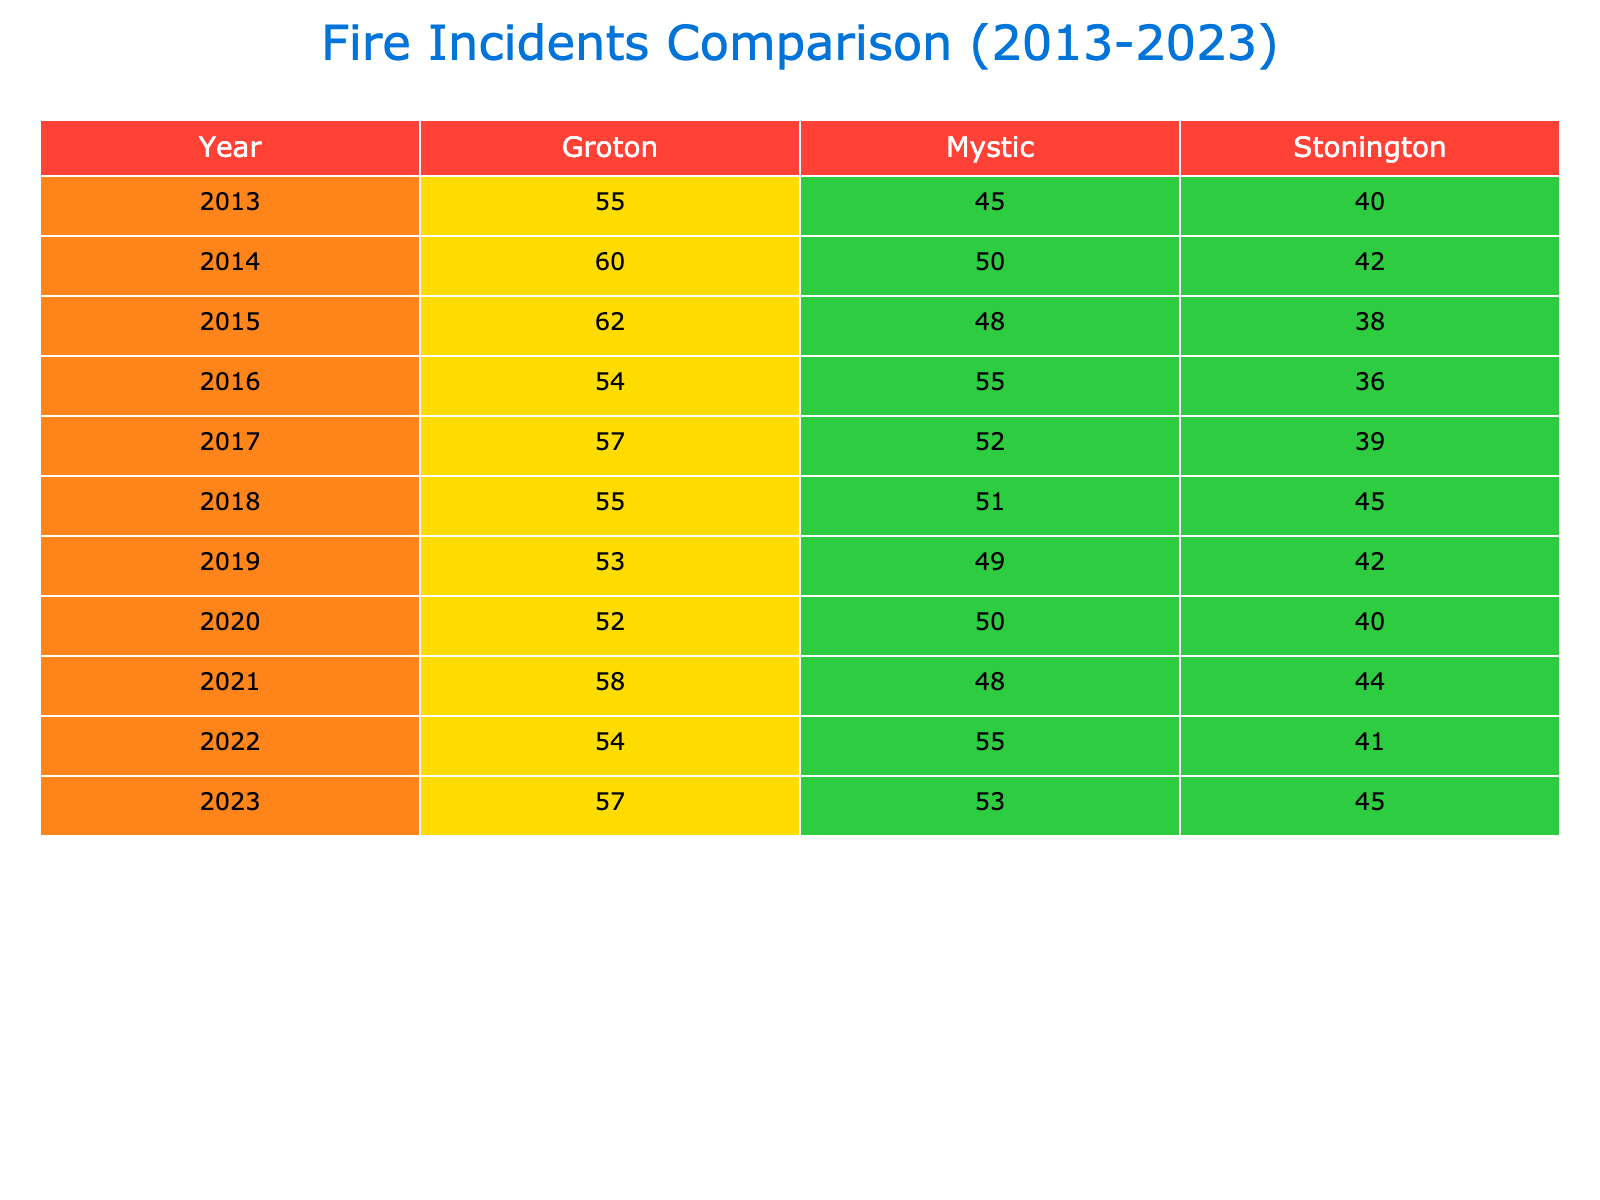What was the total number of fire incidents in Mystic in 2015? Referring to the table, in the year 2015, the column for Mystic shows a total of 48 fire incidents.
Answer: 48 Which town had the highest number of total fire incidents in 2022? Looking at the year 2022, Groton had 54 total fire incidents, which is higher than Stonington's 41 and Mystic's 55. Therefore, Mystic had the highest incidents in 2022 with 55.
Answer: Mystic How many more residential fires were reported in Groton than in Mystic in 2019? In 2019, Groton reported 31 residential fires and Mystic reported 28 residential fires. The difference is 31 - 28 = 3.
Answer: 3 Did Stonington have more than 40 total fire incidents in 2020? In the year 2020, Stonington reported a total of 40 fire incidents exactly, so the answer is not strictly more than 40, but it is equal to 40.
Answer: No What is the average number of total fire incidents across all towns in 2021? For 2021, the total incidents in Mystic were 48, Stonington 44, and Groton 58. The sum is 48 + 44 + 58 = 150. Dividing by 3 gives an average of 150 / 3 = 50.
Answer: 50 Which year recorded the fewest total fire incidents in Stonington? To find the year with the fewest incidents in Stonington, we can look at the data for Stonington across all years. The lowest total in Stonington was 36 in 2016.
Answer: 36 How many false alarms were recorded in Mystic over the decade (2013-2023)? Summing the false alarms in Mystic from 2013 to 2023: 5 + 3 + 4 + 2 + 5 + 6 + 5 + 3 + 4 = 42 false alarms were reported in total.
Answer: 42 What was the difference in total fire incidents between Mystic and Groton in 2023? In 2023, Mystic had 53 fire incidents, and Groton had 57. The difference is 57 - 53 = 4.
Answer: 4 Which town had the highest average number of total fire incidents from 2013 to 2023? First, calculate the average for each town. Mystic: (45 + 50 + 48 + 55 + 52 + 51 + 49 + 50 + 48 + 55 + 53) / 11 = 50.18. Stonington: (40 + 42 + 38 + 36 + 39 + 45 + 42 + 40 + 44 + 41 + 45) / 11 = 41.09. Groton: (55 + 60 + 62 + 54 + 57 + 55 + 53 + 52 + 58 + 54 + 57) / 11 = 55.27. Groton had the highest average.
Answer: Groton 